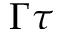<formula> <loc_0><loc_0><loc_500><loc_500>\Gamma \tau</formula> 